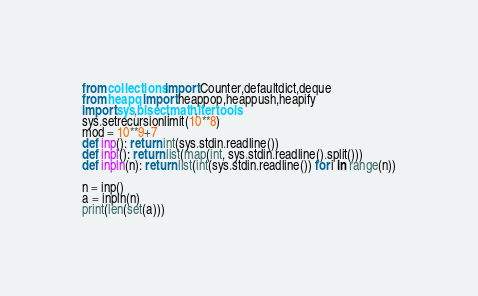Convert code to text. <code><loc_0><loc_0><loc_500><loc_500><_Python_>from collections import Counter,defaultdict,deque
from heapq import heappop,heappush,heapify
import sys,bisect,math,itertools
sys.setrecursionlimit(10**8)
mod = 10**9+7
def inp(): return int(sys.stdin.readline())
def inpl(): return list(map(int, sys.stdin.readline().split()))
def inpln(n): return list(int(sys.stdin.readline()) for i in range(n))

n = inp()
a = inpln(n)
print(len(set(a)))</code> 